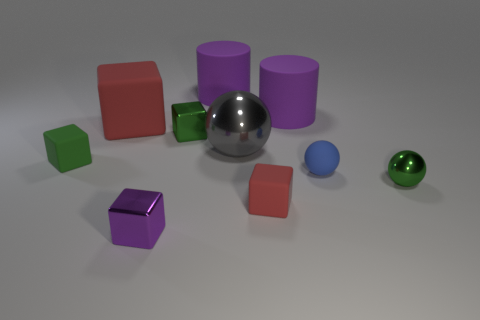Subtract all rubber spheres. How many spheres are left? 2 Subtract all purple cubes. How many cubes are left? 4 Subtract all cylinders. How many objects are left? 8 Subtract all gray spheres. How many green blocks are left? 2 Subtract 3 blocks. How many blocks are left? 2 Add 6 small red matte cubes. How many small red matte cubes are left? 7 Add 5 big gray metallic objects. How many big gray metallic objects exist? 6 Subtract 0 red balls. How many objects are left? 10 Subtract all cyan balls. Subtract all green cylinders. How many balls are left? 3 Subtract all blue objects. Subtract all small yellow blocks. How many objects are left? 9 